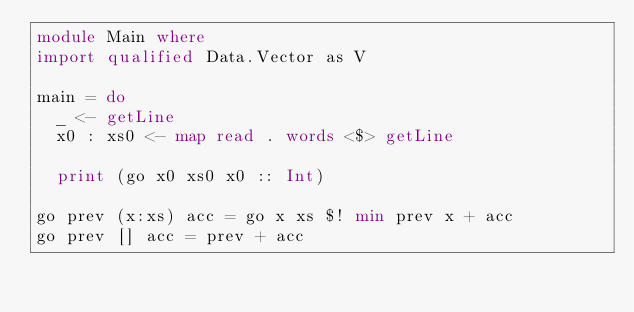Convert code to text. <code><loc_0><loc_0><loc_500><loc_500><_Haskell_>module Main where
import qualified Data.Vector as V

main = do
  _ <- getLine
  x0 : xs0 <- map read . words <$> getLine

  print (go x0 xs0 x0 :: Int)

go prev (x:xs) acc = go x xs $! min prev x + acc
go prev [] acc = prev + acc
</code> 